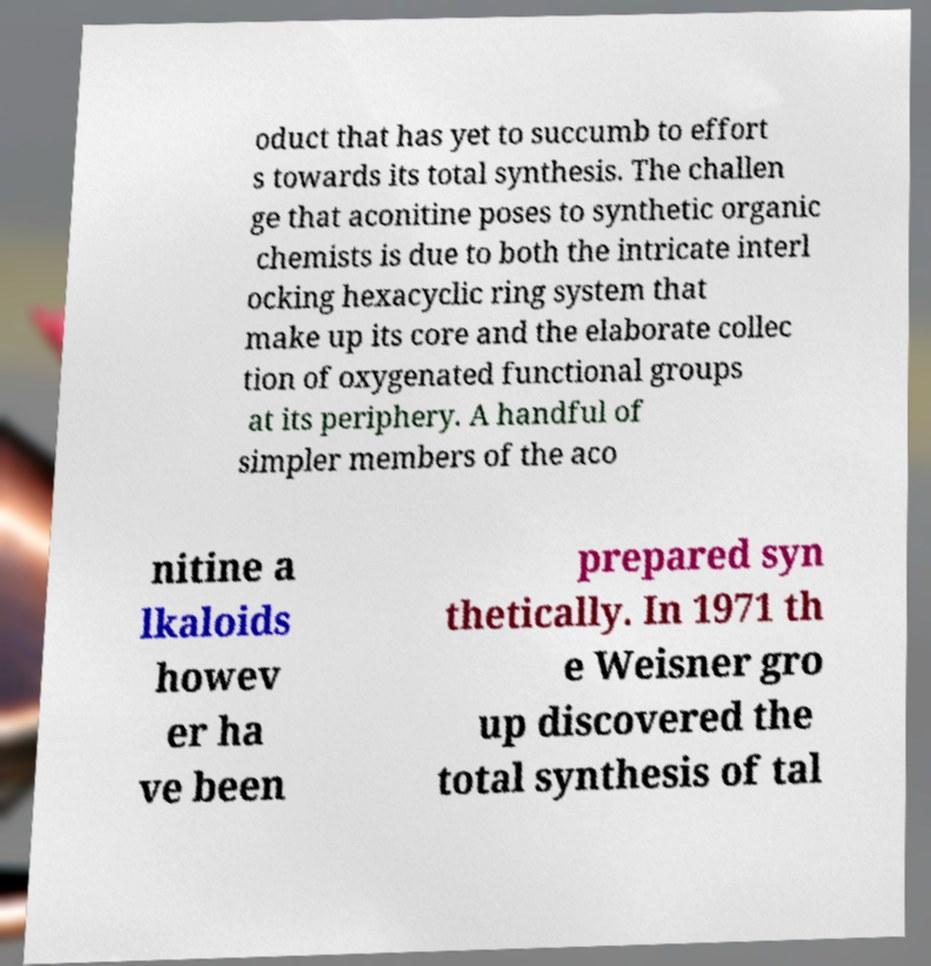Can you read and provide the text displayed in the image?This photo seems to have some interesting text. Can you extract and type it out for me? oduct that has yet to succumb to effort s towards its total synthesis. The challen ge that aconitine poses to synthetic organic chemists is due to both the intricate interl ocking hexacyclic ring system that make up its core and the elaborate collec tion of oxygenated functional groups at its periphery. A handful of simpler members of the aco nitine a lkaloids howev er ha ve been prepared syn thetically. In 1971 th e Weisner gro up discovered the total synthesis of tal 